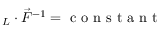Convert formula to latex. <formula><loc_0><loc_0><loc_500><loc_500>\ell _ { L } \cdot \vec { F } ^ { - 1 } = c o n s t a n t</formula> 